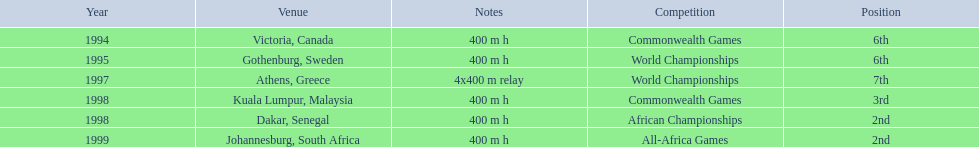What races did ken harden run? 400 m h, 400 m h, 4x400 m relay, 400 m h, 400 m h, 400 m h. Which race did ken harden run in 1997? 4x400 m relay. 